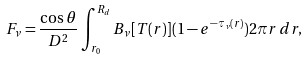Convert formula to latex. <formula><loc_0><loc_0><loc_500><loc_500>F _ { \nu } = \frac { \cos \theta } { D ^ { 2 } } \int _ { r _ { 0 } } ^ { R _ { d } } B _ { \nu } [ T ( r ) ] ( 1 - e ^ { - \tau _ { \nu } ( r ) } ) 2 \pi r \, d r ,</formula> 